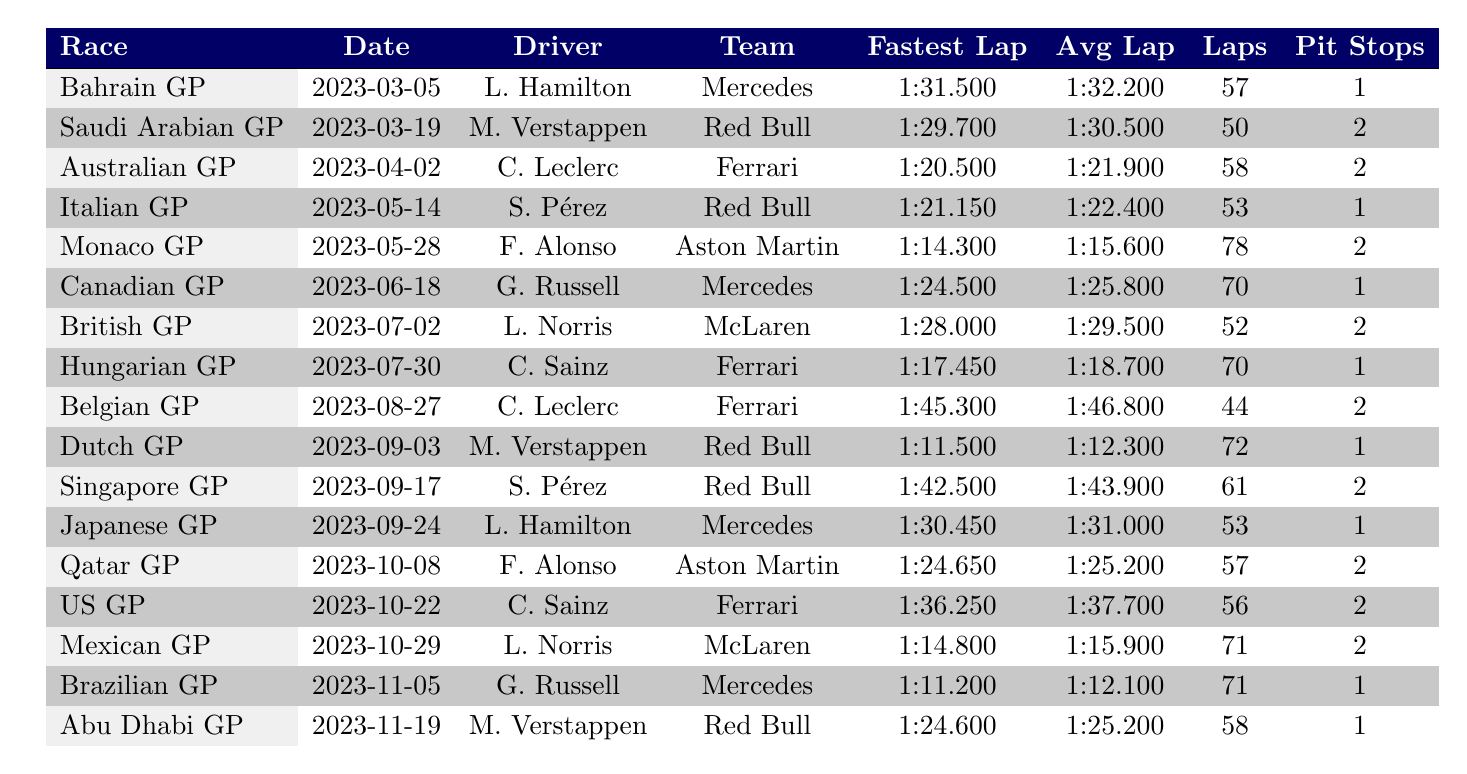What was the fastest lap time recorded by Lewis Hamilton during the 2023 season? Referring to the table, Lewis Hamilton's fastest lap time is shown in the Bahrain Grand Prix row, which states it was 1:31.500.
Answer: 1:31.500 How many laps did Charles Leclerc complete in the Australian Grand Prix? The table indicates in the Australian Grand Prix row that Charles Leclerc completed a total of 58 laps.
Answer: 58 Which driver had the highest average lap time during the races listed? To find this, we can compare all average lap times from the table. The highest average lap time is 1:46.800 from Charles Leclerc in the Belgian Grand Prix.
Answer: 1:46.800 Did Fernando Alonso have more than one pit stop in the Monaco Grand Prix? The data shows 2 pit stops for Fernando Alonso in the Monaco Grand Prix row, confirming that it is true.
Answer: Yes What is the difference in average lap time between Lewis Hamilton in the Bahrain Grand Prix and Max Verstappen in the Saudi Arabian Grand Prix? Hamilton's average lap time is 1:32.200 and Verstappen's is 1:30.500. The difference in seconds is 1:32.200 - 1:30.500 = 1.700 seconds, which is 1.700 seconds.
Answer: 1.700 seconds What was the total number of laps completed by both drivers in the longest race recorded in the table? The longest race is the Monaco Grand Prix, with 78 total laps. Since it is one race, we refer to that single number.
Answer: 78 How many drivers completed a race with an average lap time under 1:30? By checking the table, the only drivers under 1:30 in average lap time are Max Verstappen in the Saudi Arabian Grand Prix and Charles Leclerc in the Australian Grand Prix, so the count is 2.
Answer: 2 What was the total number of pit stops made by Sergio Pérez in the Dutch and Singapore Grands Prix combined? According to the table, Pérez had 1 pit stop in the Dutch Grand Prix and 2 in the Singapore Grand Prix. Adding these gives 1 + 2 = 3 pit stops.
Answer: 3 Who had the lowest fastest lap time in the races shown? Looking at the fastest lap times across all entries, the lowest fastest lap time is Fernando Alonso's 1:14.300 in the Monaco Grand Prix.
Answer: 1:14.300 